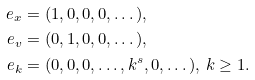<formula> <loc_0><loc_0><loc_500><loc_500>e _ { x } & = ( 1 , 0 , 0 , 0 , \dots ) , \\ e _ { v } & = ( 0 , 1 , 0 , 0 , \dots ) , \\ e _ { k } & = ( 0 , 0 , 0 , \dots , k ^ { s } , 0 , \dots ) , \, k \geq 1 .</formula> 